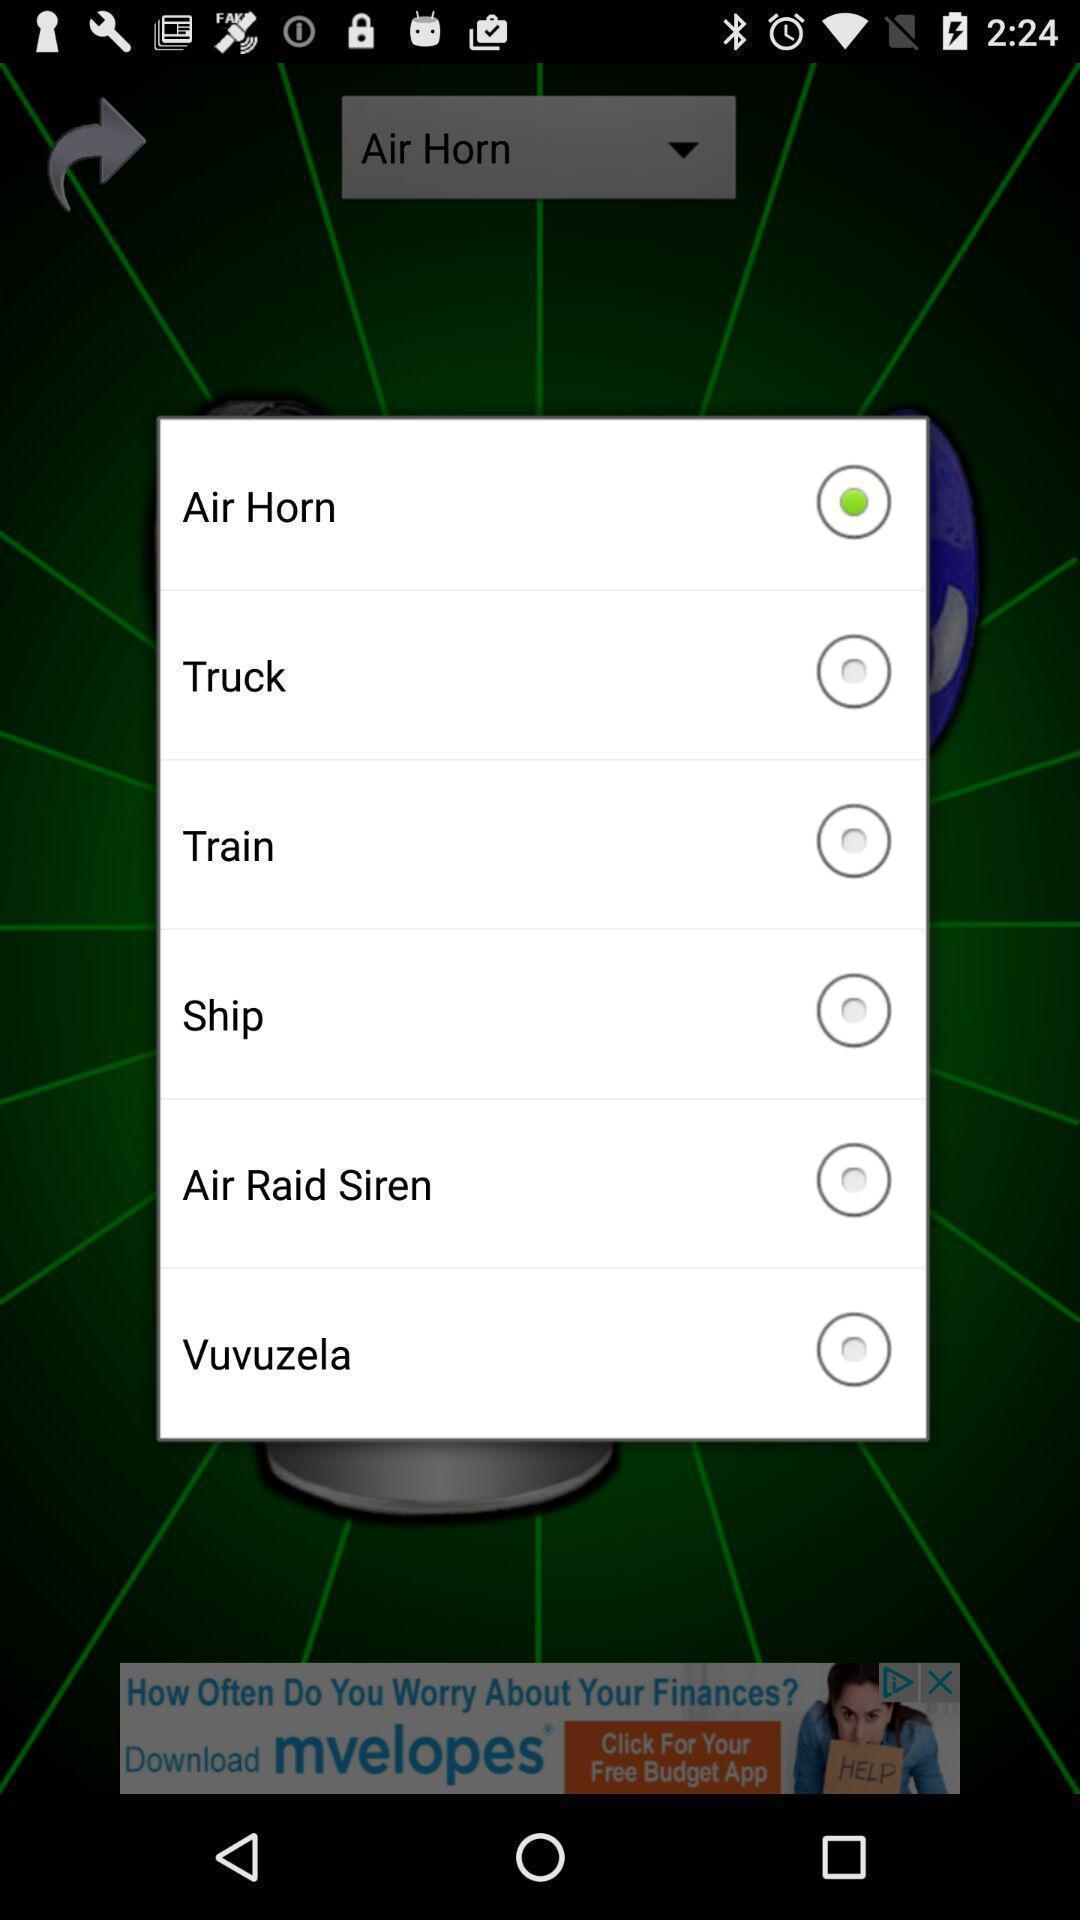Provide a detailed account of this screenshot. Pop-up displaying the list of transport options to choose. 